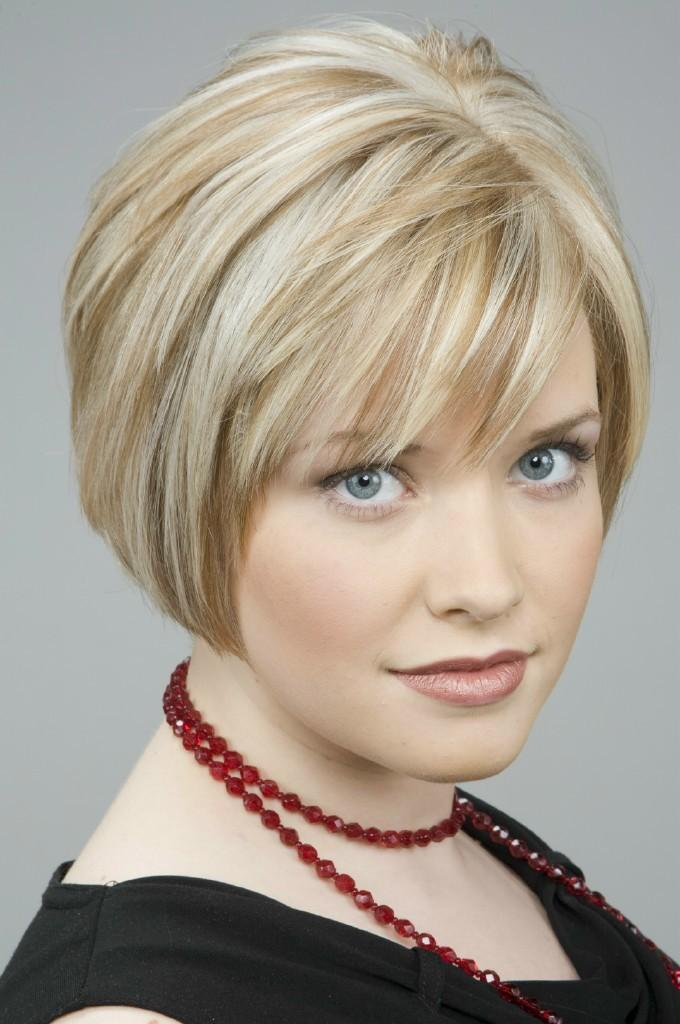Who is the main subject in the image? There is a lady in the image. What is the lady wearing? The lady is wearing a black top. Can you describe any accessories the lady is wearing? Yes, there is a chain around the lady's neck. What color is the chain? The chain is maroon in color. What type of vacation is the lady planning based on the image? There is no information in the image to suggest that the lady is planning a vacation. 